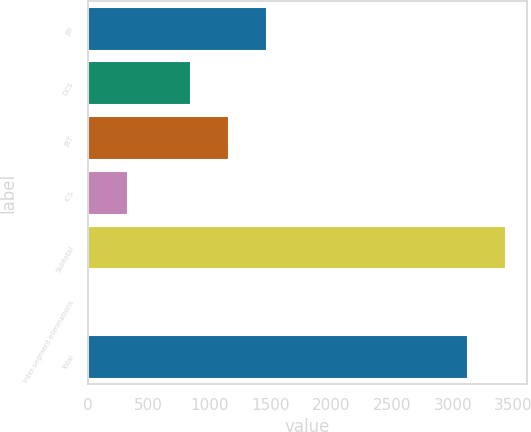Convert chart to OTSL. <chart><loc_0><loc_0><loc_500><loc_500><bar_chart><fcel>JBI<fcel>DCS<fcel>JBT<fcel>ICS<fcel>Subtotal<fcel>Inter-segment eliminations<fcel>Total<nl><fcel>1469.6<fcel>844<fcel>1156.8<fcel>332.8<fcel>3440.8<fcel>20<fcel>3128<nl></chart> 